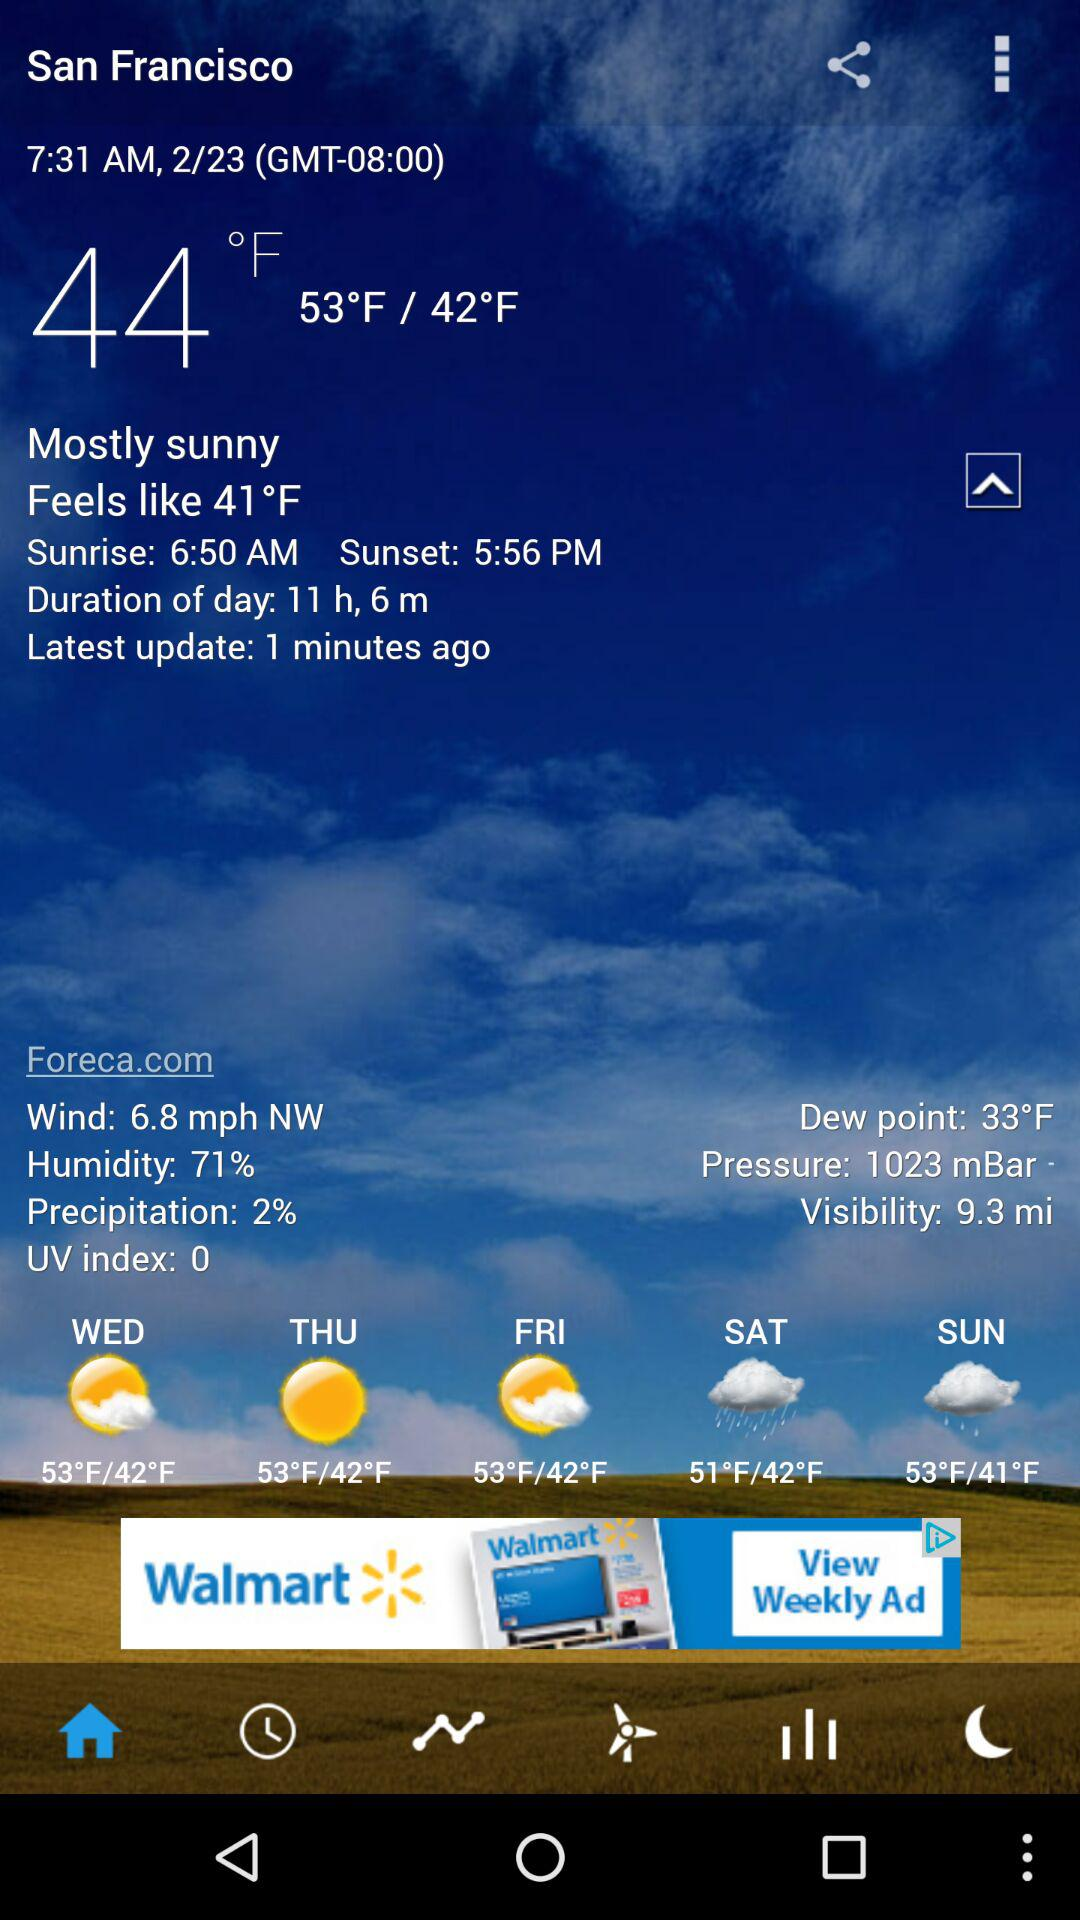What is the mentioned time? The mentioned time is 7:31 AM. 